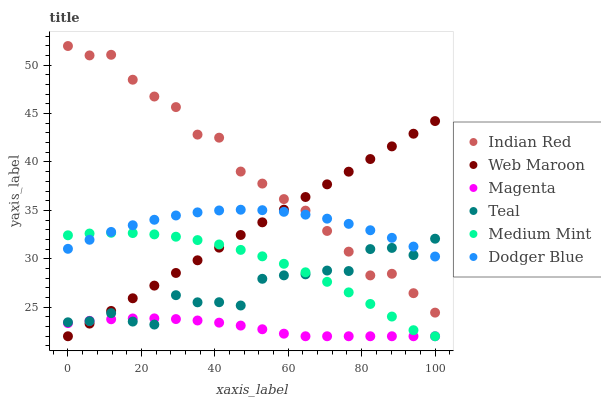Does Magenta have the minimum area under the curve?
Answer yes or no. Yes. Does Indian Red have the maximum area under the curve?
Answer yes or no. Yes. Does Web Maroon have the minimum area under the curve?
Answer yes or no. No. Does Web Maroon have the maximum area under the curve?
Answer yes or no. No. Is Web Maroon the smoothest?
Answer yes or no. Yes. Is Teal the roughest?
Answer yes or no. Yes. Is Indian Red the smoothest?
Answer yes or no. No. Is Indian Red the roughest?
Answer yes or no. No. Does Medium Mint have the lowest value?
Answer yes or no. Yes. Does Indian Red have the lowest value?
Answer yes or no. No. Does Indian Red have the highest value?
Answer yes or no. Yes. Does Web Maroon have the highest value?
Answer yes or no. No. Is Magenta less than Indian Red?
Answer yes or no. Yes. Is Indian Red greater than Magenta?
Answer yes or no. Yes. Does Medium Mint intersect Teal?
Answer yes or no. Yes. Is Medium Mint less than Teal?
Answer yes or no. No. Is Medium Mint greater than Teal?
Answer yes or no. No. Does Magenta intersect Indian Red?
Answer yes or no. No. 